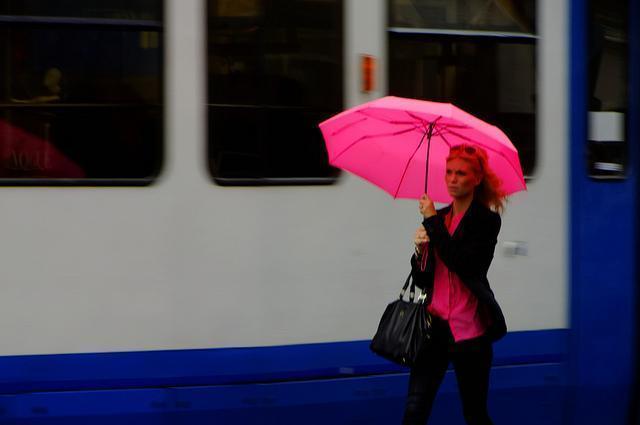Why does the woman use pink umbrella?
Answer the question by selecting the correct answer among the 4 following choices.
Options: Camouflage, sunproof, match clothes, visibility. Match clothes. 